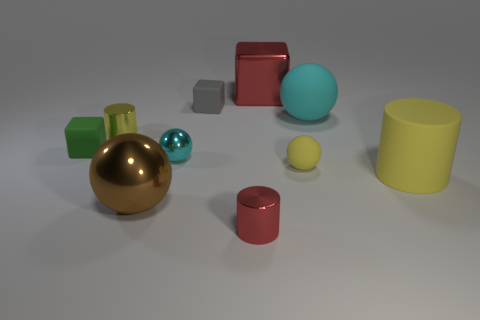The tiny thing that is the same color as the tiny matte sphere is what shape?
Keep it short and to the point. Cylinder. What is the color of the big sphere that is in front of the yellow rubber object right of the small yellow thing in front of the small cyan shiny object?
Your answer should be very brief. Brown. There is a cylinder that is the same size as the brown object; what color is it?
Offer a terse response. Yellow. Is the color of the shiny cube the same as the shiny cylinder on the right side of the gray matte object?
Give a very brief answer. Yes. There is a tiny cylinder that is to the right of the small cyan sphere in front of the cyan matte sphere; what is its material?
Provide a succinct answer. Metal. How many things are both to the left of the cyan matte object and behind the yellow shiny thing?
Ensure brevity in your answer.  2. What number of other things are there of the same size as the green cube?
Ensure brevity in your answer.  5. Do the small yellow thing on the left side of the large brown metallic ball and the red thing behind the cyan rubber object have the same shape?
Make the answer very short. No. There is a metal cube; are there any yellow shiny cylinders behind it?
Your answer should be very brief. No. What color is the large metal thing that is the same shape as the big cyan matte thing?
Provide a short and direct response. Brown. 